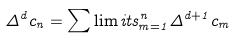<formula> <loc_0><loc_0><loc_500><loc_500>\Delta ^ { d } c _ { n } = \sum \lim i t s _ { m = 1 } ^ { n } \Delta ^ { d + 1 } c _ { m }</formula> 